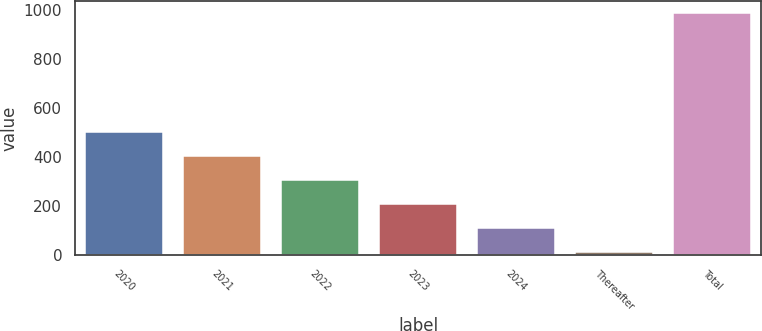Convert chart. <chart><loc_0><loc_0><loc_500><loc_500><bar_chart><fcel>2020<fcel>2021<fcel>2022<fcel>2023<fcel>2024<fcel>Thereafter<fcel>Total<nl><fcel>500.5<fcel>403.2<fcel>305.9<fcel>208.6<fcel>111.3<fcel>14<fcel>987<nl></chart> 